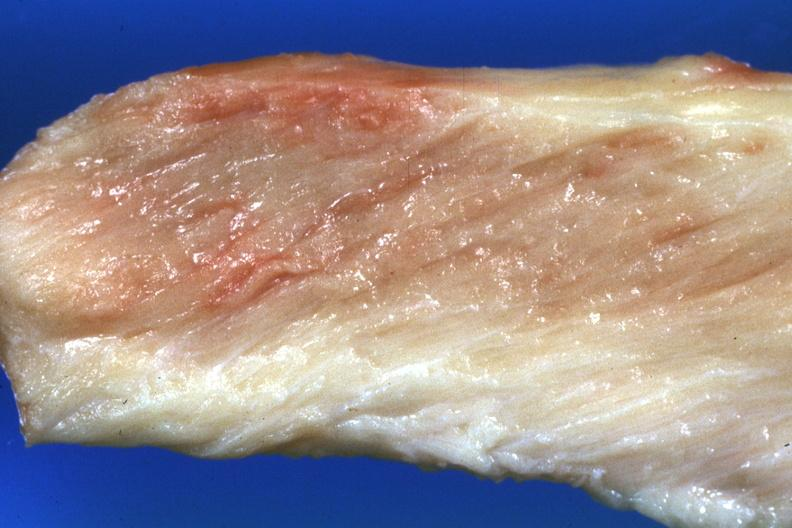does mixed mesodermal tumor show close-up view pale muscle?
Answer the question using a single word or phrase. No 